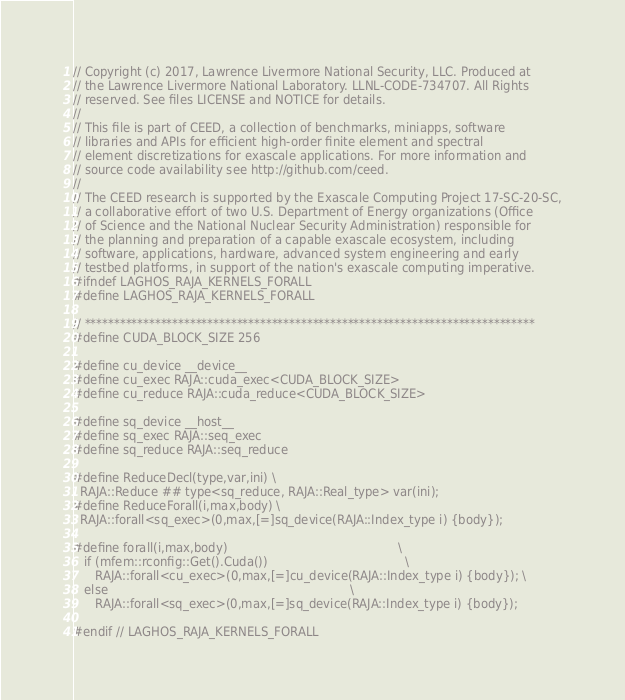Convert code to text. <code><loc_0><loc_0><loc_500><loc_500><_C++_>// Copyright (c) 2017, Lawrence Livermore National Security, LLC. Produced at
// the Lawrence Livermore National Laboratory. LLNL-CODE-734707. All Rights
// reserved. See files LICENSE and NOTICE for details.
//
// This file is part of CEED, a collection of benchmarks, miniapps, software
// libraries and APIs for efficient high-order finite element and spectral
// element discretizations for exascale applications. For more information and
// source code availability see http://github.com/ceed.
//
// The CEED research is supported by the Exascale Computing Project 17-SC-20-SC,
// a collaborative effort of two U.S. Department of Energy organizations (Office
// of Science and the National Nuclear Security Administration) responsible for
// the planning and preparation of a capable exascale ecosystem, including
// software, applications, hardware, advanced system engineering and early
// testbed platforms, in support of the nation's exascale computing imperative.
#ifndef LAGHOS_RAJA_KERNELS_FORALL
#define LAGHOS_RAJA_KERNELS_FORALL

// *****************************************************************************
#define CUDA_BLOCK_SIZE 256

#define cu_device __device__
#define cu_exec RAJA::cuda_exec<CUDA_BLOCK_SIZE>
#define cu_reduce RAJA::cuda_reduce<CUDA_BLOCK_SIZE>

#define sq_device __host__
#define sq_exec RAJA::seq_exec
#define sq_reduce RAJA::seq_reduce

#define ReduceDecl(type,var,ini) \
  RAJA::Reduce ## type<sq_reduce, RAJA::Real_type> var(ini);
#define ReduceForall(i,max,body) \
  RAJA::forall<sq_exec>(0,max,[=]sq_device(RAJA::Index_type i) {body});

#define forall(i,max,body)                                              \
   if (mfem::rconfig::Get().Cuda())                                     \
      RAJA::forall<cu_exec>(0,max,[=]cu_device(RAJA::Index_type i) {body}); \
   else                                                                 \
      RAJA::forall<sq_exec>(0,max,[=]sq_device(RAJA::Index_type i) {body});

#endif // LAGHOS_RAJA_KERNELS_FORALL
</code> 